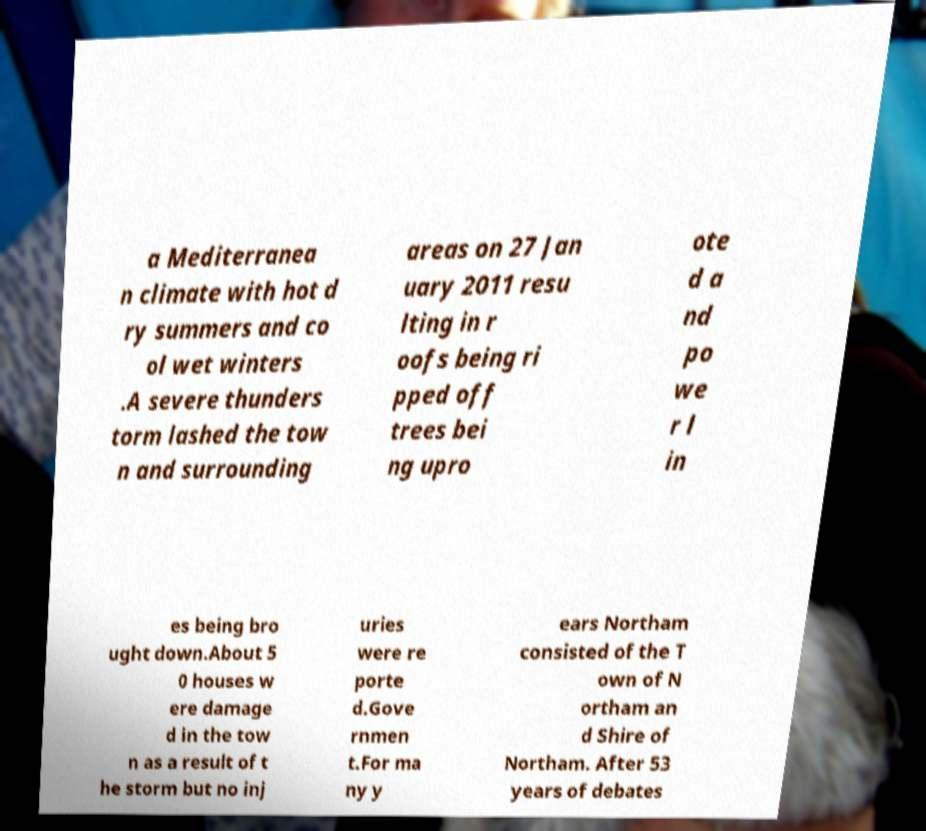Can you accurately transcribe the text from the provided image for me? a Mediterranea n climate with hot d ry summers and co ol wet winters .A severe thunders torm lashed the tow n and surrounding areas on 27 Jan uary 2011 resu lting in r oofs being ri pped off trees bei ng upro ote d a nd po we r l in es being bro ught down.About 5 0 houses w ere damage d in the tow n as a result of t he storm but no inj uries were re porte d.Gove rnmen t.For ma ny y ears Northam consisted of the T own of N ortham an d Shire of Northam. After 53 years of debates 